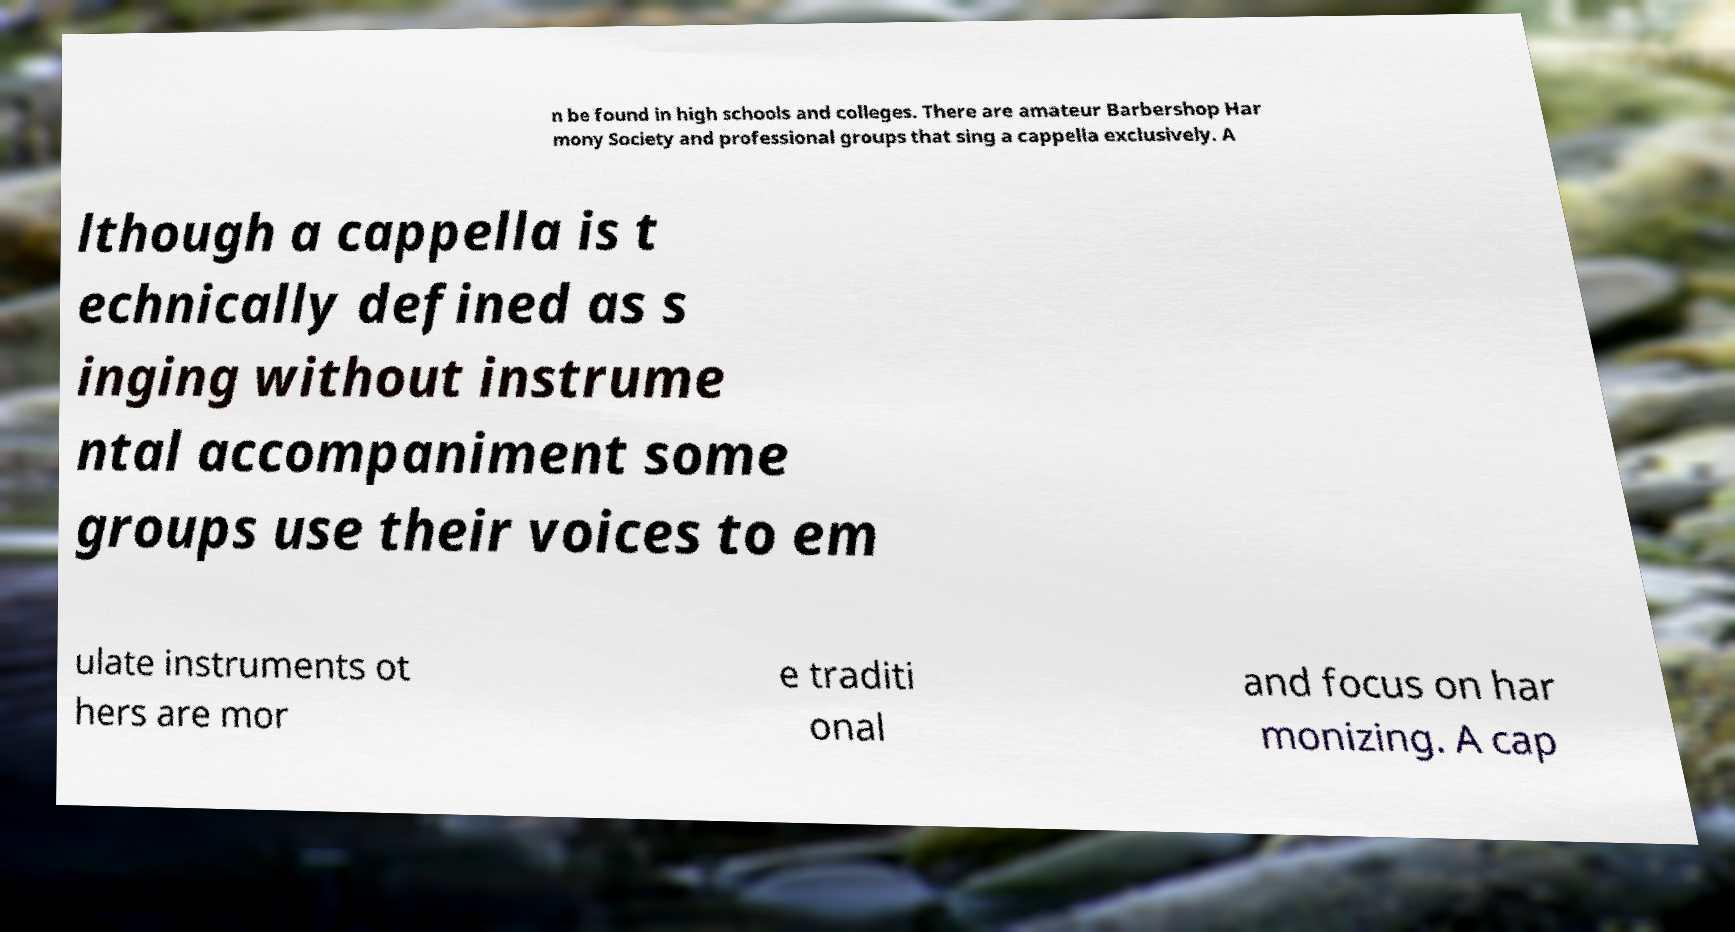For documentation purposes, I need the text within this image transcribed. Could you provide that? n be found in high schools and colleges. There are amateur Barbershop Har mony Society and professional groups that sing a cappella exclusively. A lthough a cappella is t echnically defined as s inging without instrume ntal accompaniment some groups use their voices to em ulate instruments ot hers are mor e traditi onal and focus on har monizing. A cap 